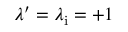<formula> <loc_0><loc_0><loc_500><loc_500>\lambda ^ { \prime } = \lambda _ { i } = + 1</formula> 